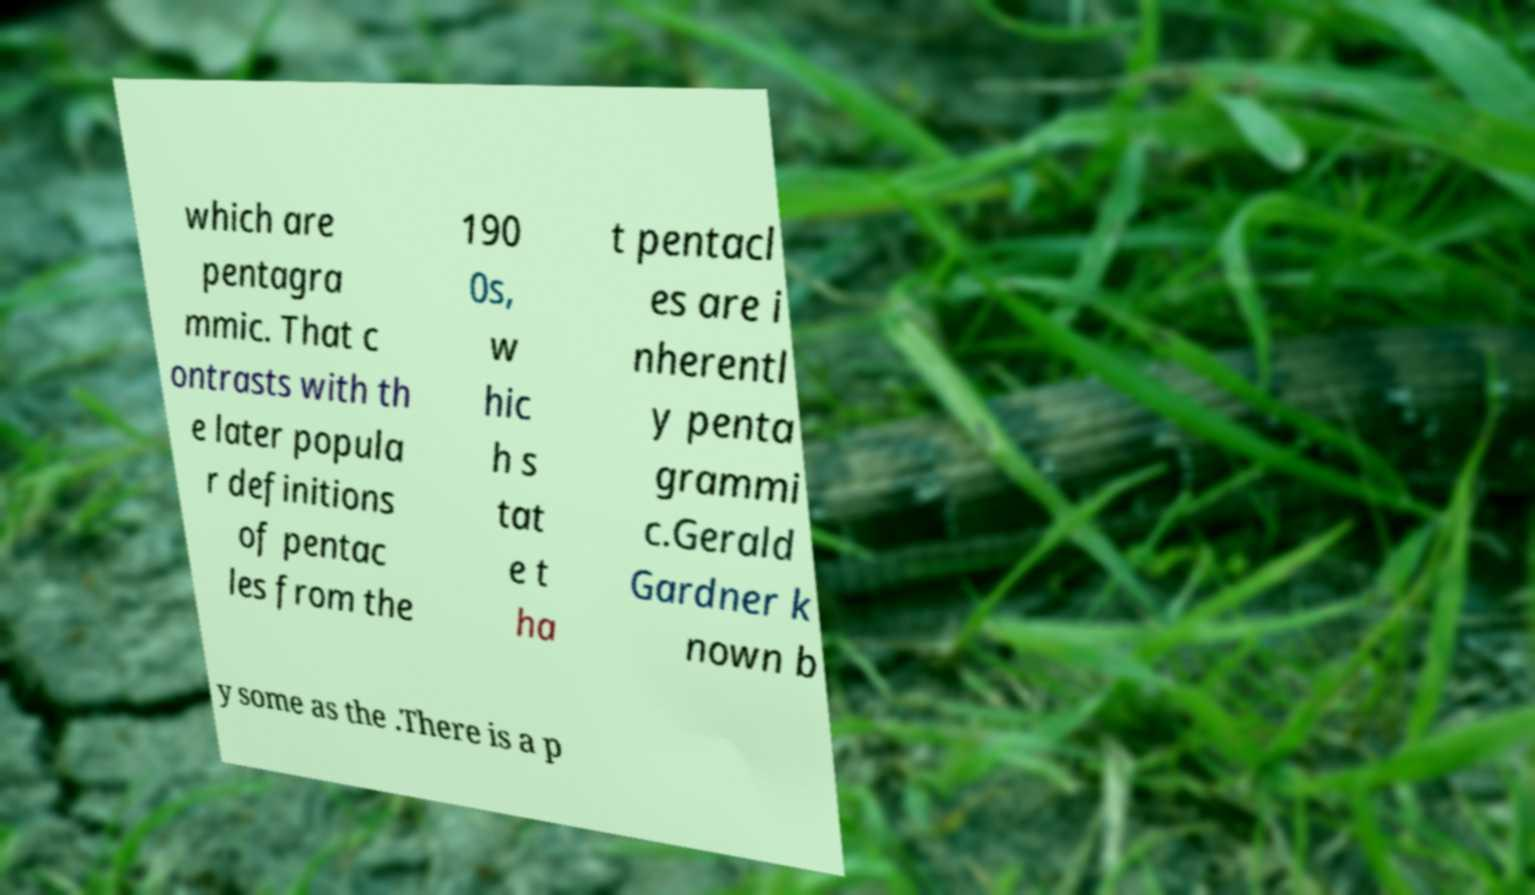There's text embedded in this image that I need extracted. Can you transcribe it verbatim? which are pentagra mmic. That c ontrasts with th e later popula r definitions of pentac les from the 190 0s, w hic h s tat e t ha t pentacl es are i nherentl y penta grammi c.Gerald Gardner k nown b y some as the .There is a p 